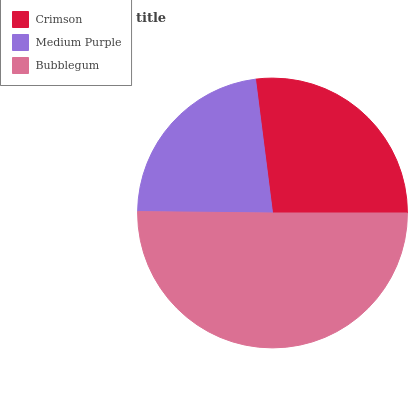Is Medium Purple the minimum?
Answer yes or no. Yes. Is Bubblegum the maximum?
Answer yes or no. Yes. Is Bubblegum the minimum?
Answer yes or no. No. Is Medium Purple the maximum?
Answer yes or no. No. Is Bubblegum greater than Medium Purple?
Answer yes or no. Yes. Is Medium Purple less than Bubblegum?
Answer yes or no. Yes. Is Medium Purple greater than Bubblegum?
Answer yes or no. No. Is Bubblegum less than Medium Purple?
Answer yes or no. No. Is Crimson the high median?
Answer yes or no. Yes. Is Crimson the low median?
Answer yes or no. Yes. Is Medium Purple the high median?
Answer yes or no. No. Is Bubblegum the low median?
Answer yes or no. No. 